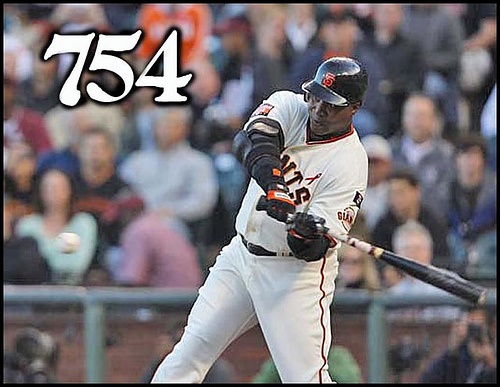Describe the objects in this image and their specific colors. I can see people in black, lightgray, darkgray, and gray tones, people in black, darkgray, and gray tones, people in black, gray, darkgray, and lightblue tones, people in black, darkgray, and gray tones, and people in black and gray tones in this image. 